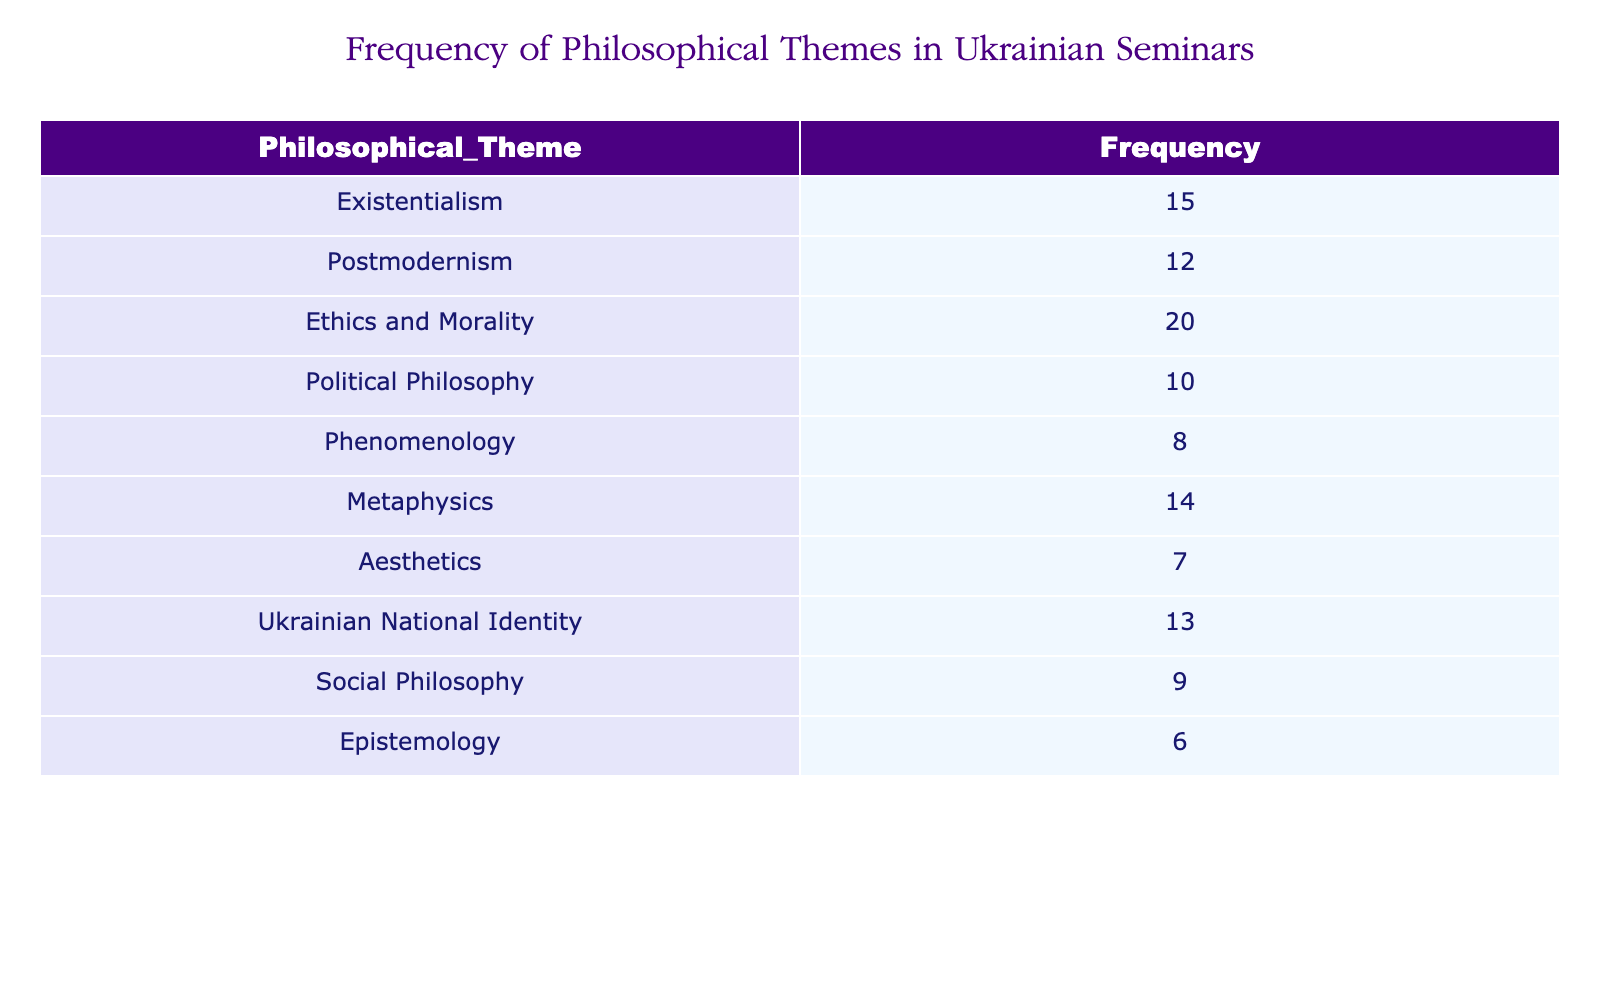What is the frequency of discussions on Ethics and Morality? The table shows that the frequency of discussions specifically about Ethics and Morality is listed directly as 20.
Answer: 20 Which philosophical theme has the lowest frequency? By examining the frequencies listed, we see that Epistemology has the lowest frequency at 6.
Answer: Epistemology What is the sum of frequencies for Existentialism and Political Philosophy? The frequency for Existentialism is 15, and for Political Philosophy, it is 10. Summing these gives 15 + 10 = 25.
Answer: 25 Is Political Philosophy discussed more frequently than Aesthetics? Looking at the table, Political Philosophy has a frequency of 10, whereas Aesthetics has 7. Thus, Political Philosophy is discussed more frequently.
Answer: Yes What is the average frequency of the philosophical themes listed in the table? To find the average, sum all the frequencies: 15 + 12 + 20 + 10 + 8 + 14 + 7 + 13 + 9 + 6 = 124. There are 10 themes, so the average is 124 / 10 = 12.4.
Answer: 12.4 How many more discussions are held on Metaphysics than on Aesthetics? Metaphysics has a frequency of 14, while Aesthetics has 7. The difference is 14 - 7 = 7, meaning there are 7 more discussions on Metaphysics.
Answer: 7 Which themes have a frequency of 12 or more? The themes are Existentialism (15), Postmodernism (12), Ethics and Morality (20), Metaphysics (14), Ukrainian National Identity (13). Therefore, five themes have a frequency of 12 or higher.
Answer: Five themes If we remove the frequency of Social Philosophy, what will be the new total frequency of the remaining themes? The current total is 124. Social Philosophy has a frequency of 9. Removing this gives 124 - 9 = 115 as the new total frequency.
Answer: 115 How many themes have a frequency of less than 10? By checking the table, we see that Aesthetics (7), Epistemology (6), and Social Philosophy (9) are the only themes with frequencies less than 10. This totals to 3 themes.
Answer: 3 Is the frequency of discussions on Ukrainian National Identity greater than that of Phenomenology? The table shows that Ukrainian National Identity has a frequency of 13, while Phenomenology has 8. Therefore, Ukrainian National Identity is discussed more frequently.
Answer: Yes 